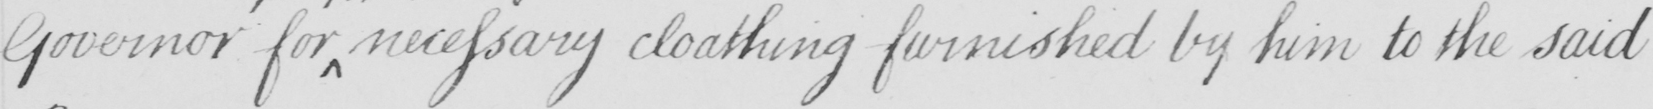What is written in this line of handwriting? Governor for necessary cloathing furnished by him to the said 